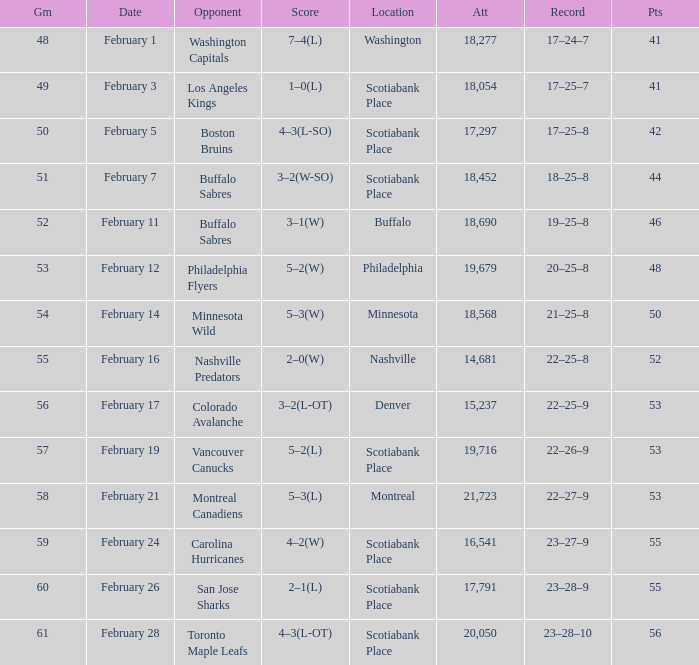What average game was held on february 24 and has an attendance smaller than 16,541? None. 